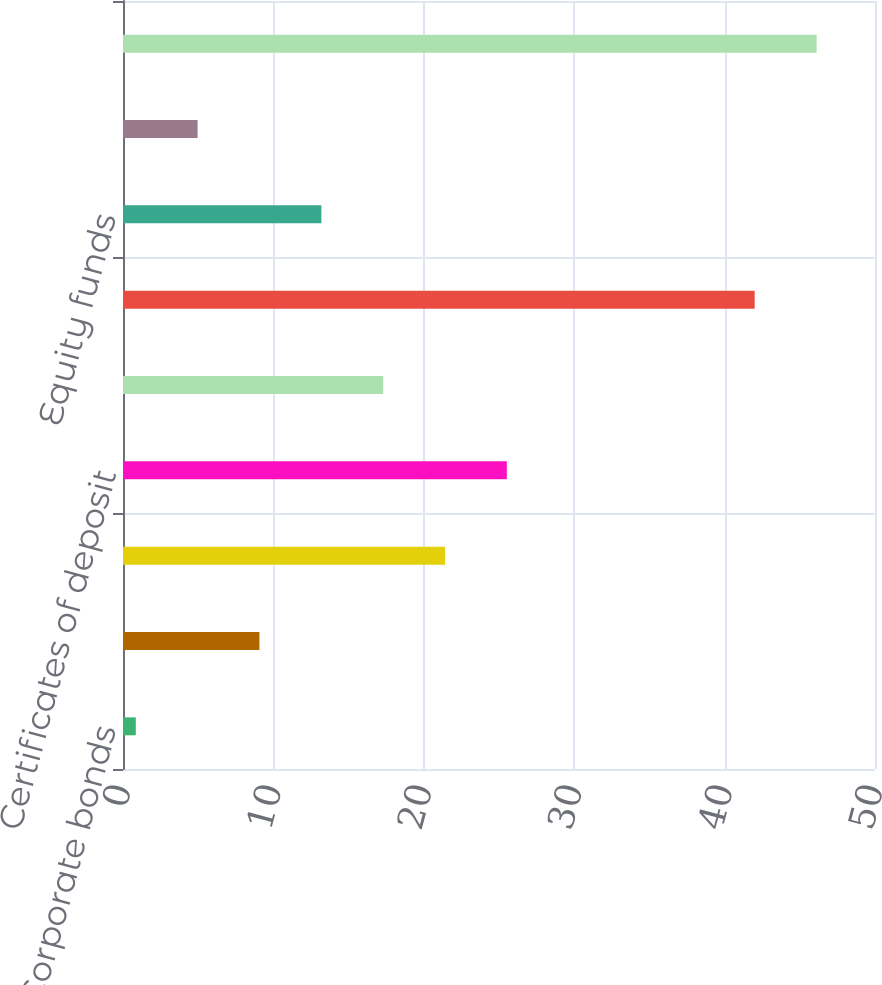<chart> <loc_0><loc_0><loc_500><loc_500><bar_chart><fcel>Corporate bonds<fcel>US Treasury and government<fcel>Commercial paper<fcel>Certificates of deposit<fcel>Money market funds<fcel>Auction rate securities<fcel>Equity funds<fcel>Foreign currency contracts<fcel>Total<nl><fcel>0.85<fcel>9.07<fcel>21.41<fcel>25.52<fcel>17.3<fcel>42<fcel>13.19<fcel>4.96<fcel>46.12<nl></chart> 